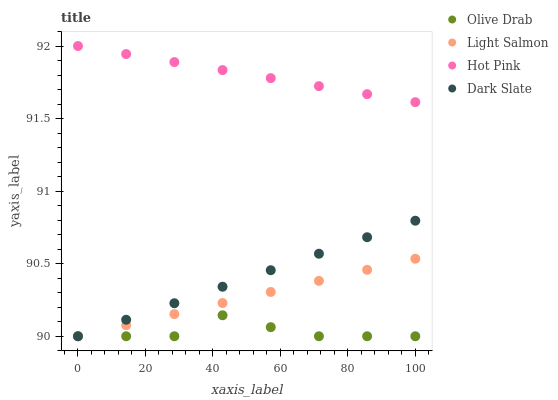Does Olive Drab have the minimum area under the curve?
Answer yes or no. Yes. Does Hot Pink have the maximum area under the curve?
Answer yes or no. Yes. Does Light Salmon have the minimum area under the curve?
Answer yes or no. No. Does Light Salmon have the maximum area under the curve?
Answer yes or no. No. Is Hot Pink the smoothest?
Answer yes or no. Yes. Is Olive Drab the roughest?
Answer yes or no. Yes. Is Light Salmon the smoothest?
Answer yes or no. No. Is Light Salmon the roughest?
Answer yes or no. No. Does Dark Slate have the lowest value?
Answer yes or no. Yes. Does Hot Pink have the lowest value?
Answer yes or no. No. Does Hot Pink have the highest value?
Answer yes or no. Yes. Does Light Salmon have the highest value?
Answer yes or no. No. Is Dark Slate less than Hot Pink?
Answer yes or no. Yes. Is Hot Pink greater than Light Salmon?
Answer yes or no. Yes. Does Dark Slate intersect Light Salmon?
Answer yes or no. Yes. Is Dark Slate less than Light Salmon?
Answer yes or no. No. Is Dark Slate greater than Light Salmon?
Answer yes or no. No. Does Dark Slate intersect Hot Pink?
Answer yes or no. No. 